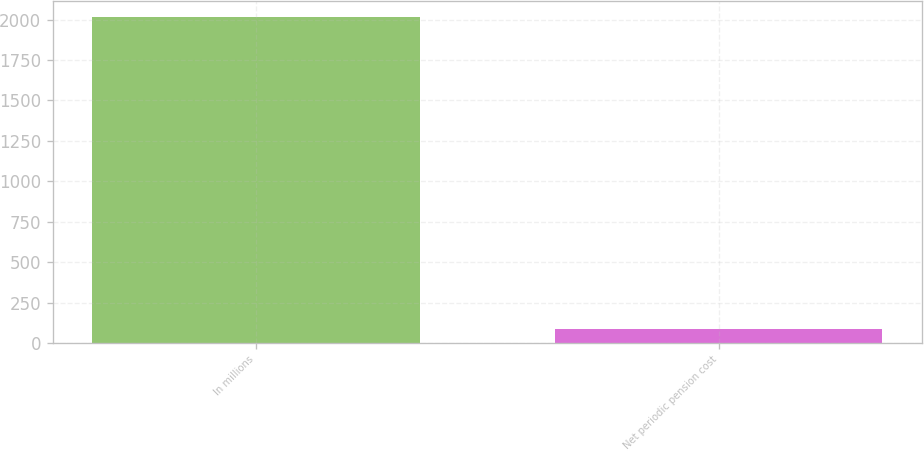Convert chart to OTSL. <chart><loc_0><loc_0><loc_500><loc_500><bar_chart><fcel>In millions<fcel>Net periodic pension cost<nl><fcel>2013<fcel>87<nl></chart> 